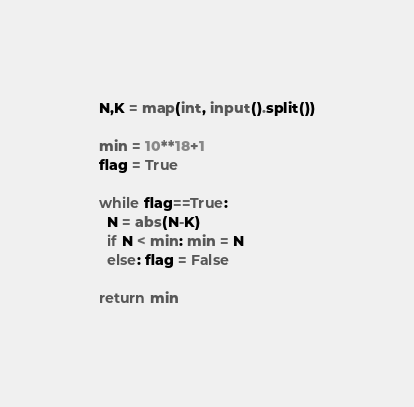Convert code to text. <code><loc_0><loc_0><loc_500><loc_500><_Python_>N,K = map(int, input().split())

min = 10**18+1
flag = True

while flag==True:
  N = abs(N-K)
  if N < min: min = N
  else: flag = False
    
return min
</code> 